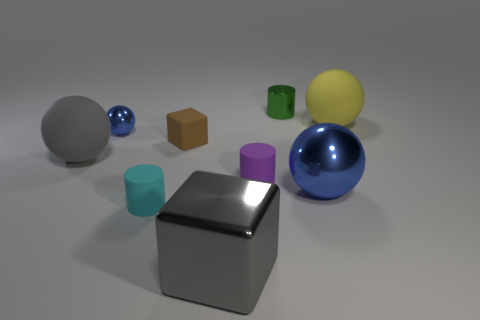Subtract all spheres. How many objects are left? 5 Subtract all tiny blue metal cylinders. Subtract all blue shiny balls. How many objects are left? 7 Add 4 brown objects. How many brown objects are left? 5 Add 8 small rubber spheres. How many small rubber spheres exist? 8 Subtract 1 green cylinders. How many objects are left? 8 